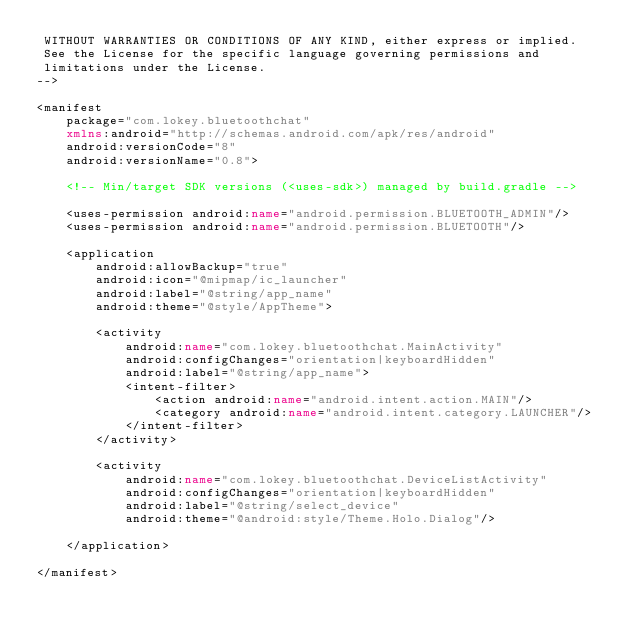Convert code to text. <code><loc_0><loc_0><loc_500><loc_500><_XML_> WITHOUT WARRANTIES OR CONDITIONS OF ANY KIND, either express or implied.
 See the License for the specific language governing permissions and
 limitations under the License.
-->

<manifest
    package="com.lokey.bluetoothchat"
    xmlns:android="http://schemas.android.com/apk/res/android"
    android:versionCode="8"
    android:versionName="0.8">

    <!-- Min/target SDK versions (<uses-sdk>) managed by build.gradle -->

    <uses-permission android:name="android.permission.BLUETOOTH_ADMIN"/>
    <uses-permission android:name="android.permission.BLUETOOTH"/>

    <application
        android:allowBackup="true"
        android:icon="@mipmap/ic_launcher"
        android:label="@string/app_name"
        android:theme="@style/AppTheme">

        <activity
            android:name="com.lokey.bluetoothchat.MainActivity"
            android:configChanges="orientation|keyboardHidden"
            android:label="@string/app_name">
            <intent-filter>
                <action android:name="android.intent.action.MAIN"/>
                <category android:name="android.intent.category.LAUNCHER"/>
            </intent-filter>
        </activity>

        <activity
            android:name="com.lokey.bluetoothchat.DeviceListActivity"
            android:configChanges="orientation|keyboardHidden"
            android:label="@string/select_device"
            android:theme="@android:style/Theme.Holo.Dialog"/>

    </application>

</manifest>
</code> 